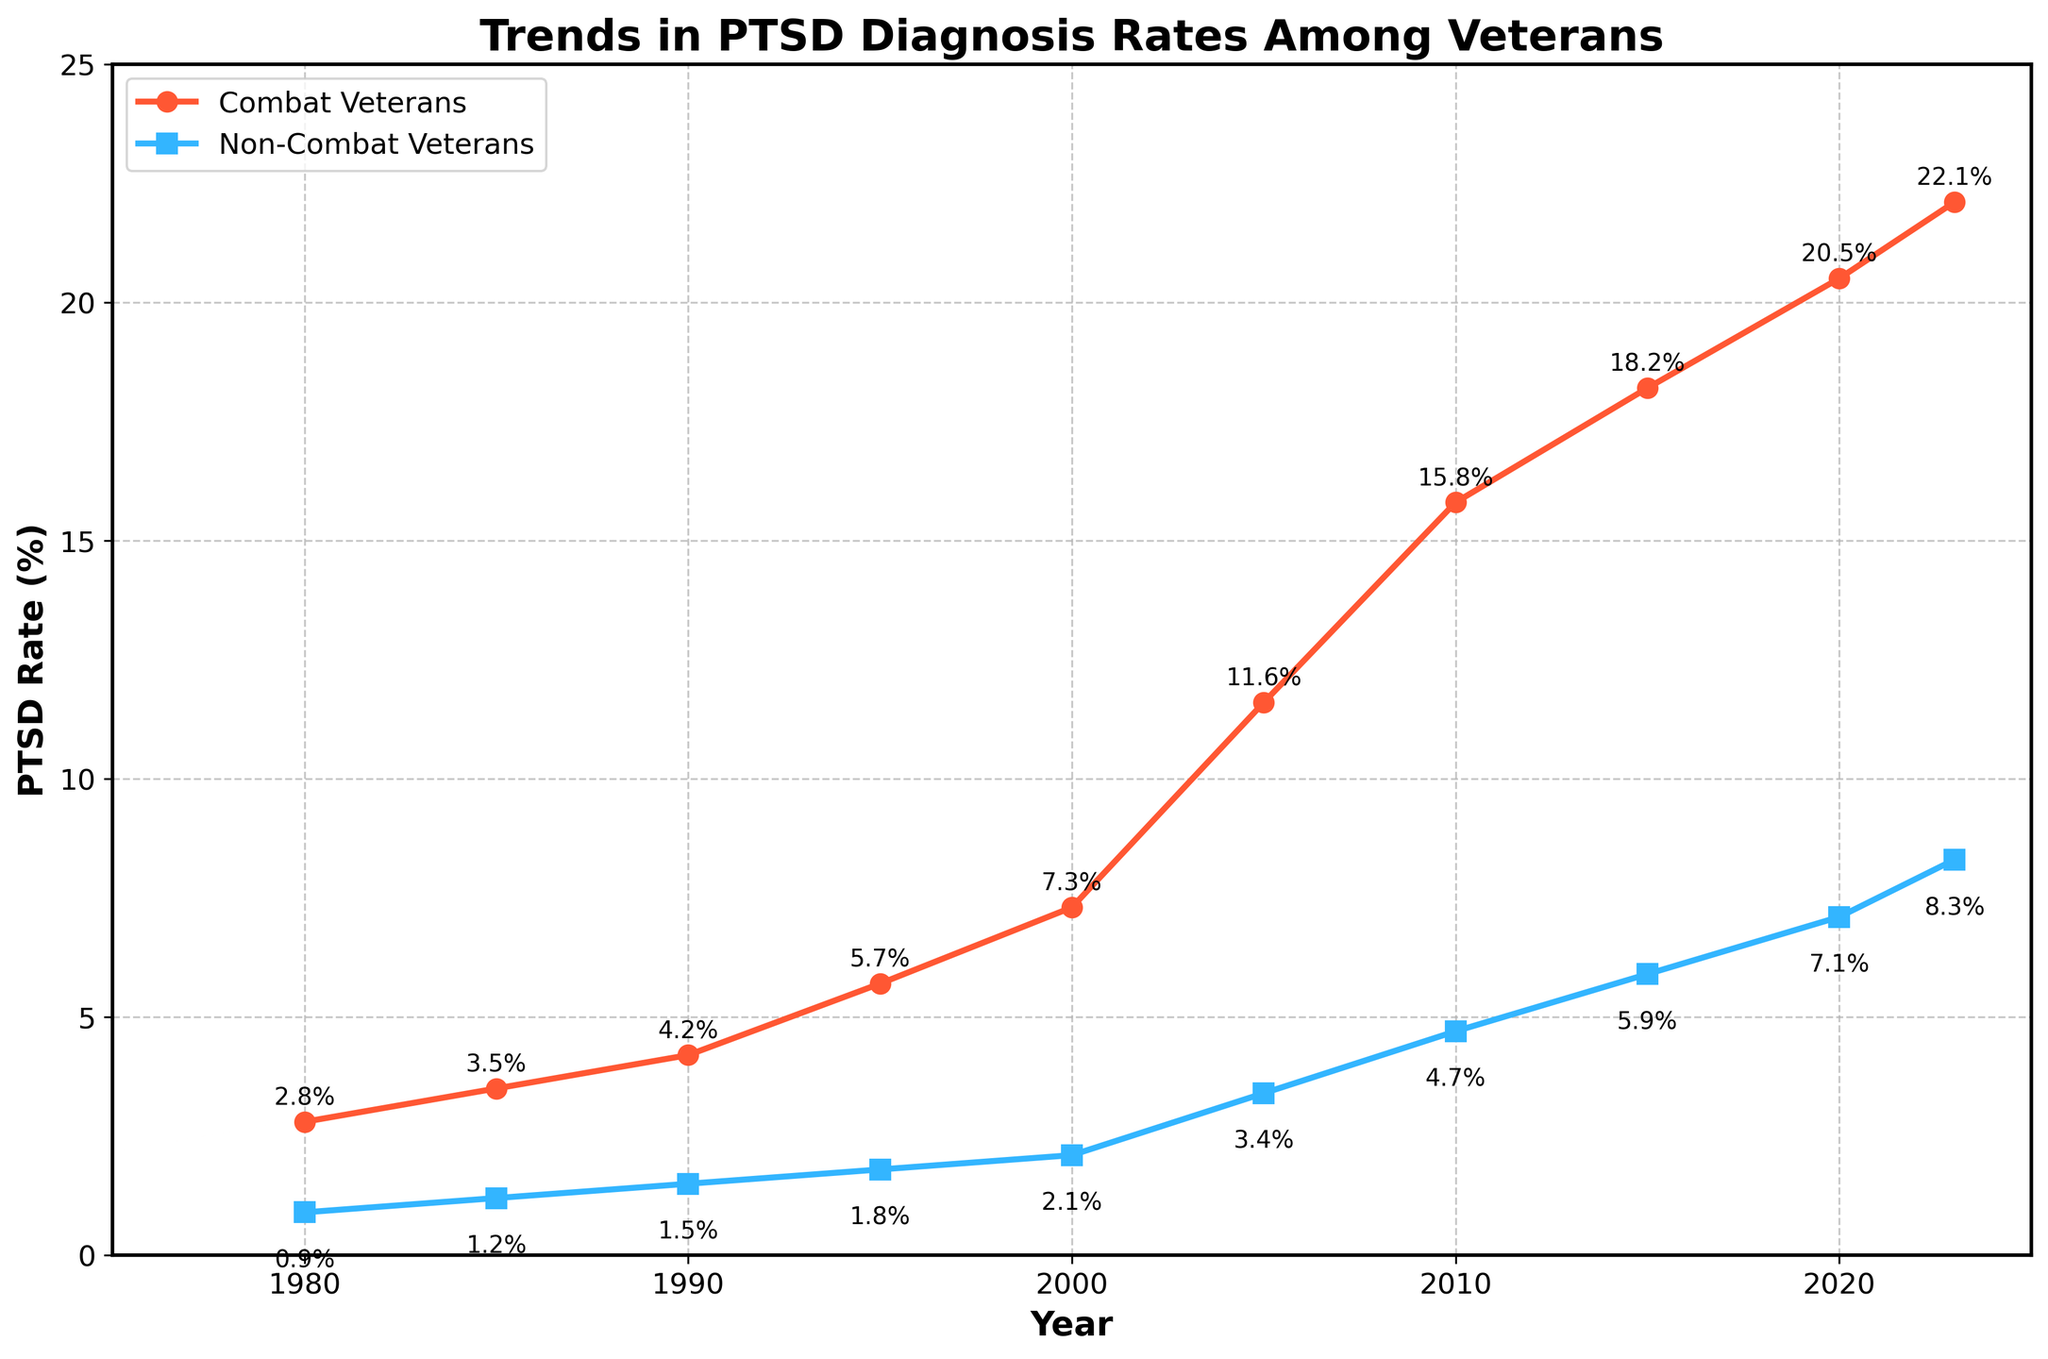What is the PTSD diagnosis rate of combat veterans in 1990? The figure shows the PTSD rates for combat veterans in different years. By looking at 1990, you can see the rate marked.
Answer: 4.2% What is the percentage increase in PTSD rates among non-combat veterans from 1980 to 2023? To calculate the percentage increase, subtract the rate in 1980 from the rate in 2023, then divide by the rate in 1980, and multiply by 100. (8.3 - 0.9) / 0.9 * 100 = 822.22%.
Answer: 822.22% Which year shows the highest PTSD rate increase for combat veterans compared to the previous recorded year? Look for the largest difference between consecutive data points for combat veterans. The greatest increase occurs between 2000 and 2005. (11.6 - 7.3) = 4.3%.
Answer: 2005 In 2020, how much higher is the PTSD rate for combat veterans compared to non-combat veterans? Subtract the PTSD rate for non-combat veterans from the PTSD rate for combat veterans in 2020. 20.5 - 7.1 = 13.4%.
Answer: 13.4% What is the average PTSD rate for non-combat veterans over the years recorded in the plot? Sum the PTSD rates for non-combat veterans and divide by the number of years. (0.9 + 1.2 + 1.5 + 1.8 + 2.1 + 3.4 + 4.7 + 5.9 + 7.1 + 8.3) / 10 = 3.69%.
Answer: 3.69% Between which two consecutive years did non-combat veterans see the smallest increase in PTSD rate? Look for the smallest difference between consecutive data points for non-combat veterans. The smallest increase was between 1990 and 1995. (1.8 - 1.5) = 0.3%.
Answer: 1990 and 1995 What is the visual difference between the markers for combat veterans and non-combat veterans? The figure uses different shapes and colors for markers: combat veterans are represented by red circles, and non-combat veterans by blue squares.
Answer: red circles and blue squares Compare the overall trends in PTSD rates for combat and non-combat veterans from 1980 to 2023. The PTSD rates for both groups increase over time, but the combat veterans' rates rise much more steeply compared to non-combat veterans, indicating a larger disparity.
Answer: steeper increase for combat veterans In which year did the PTSD rate of combat veterans exceed the highest recorded PTSD rate of non-combat veterans? Identify the year where the combat veterans' PTSD rate first exceeds 8.3%, the highest rate for non-combat veterans. In 2005, 11.6% > 8.3%.
Answer: 2005 Find the year with the largest absolute difference in PTSD rates between combat and non-combat veterans. Subtract the non-combat veterans' rate from combat veterans' rate for each year and find the maximum difference. 2020 has the largest difference: 20.5 - 7.1 = 13.4%.
Answer: 2020 